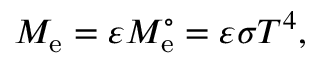Convert formula to latex. <formula><loc_0><loc_0><loc_500><loc_500>M _ { e } = \varepsilon M _ { e } ^ { \circ } = \varepsilon \sigma T ^ { 4 } ,</formula> 